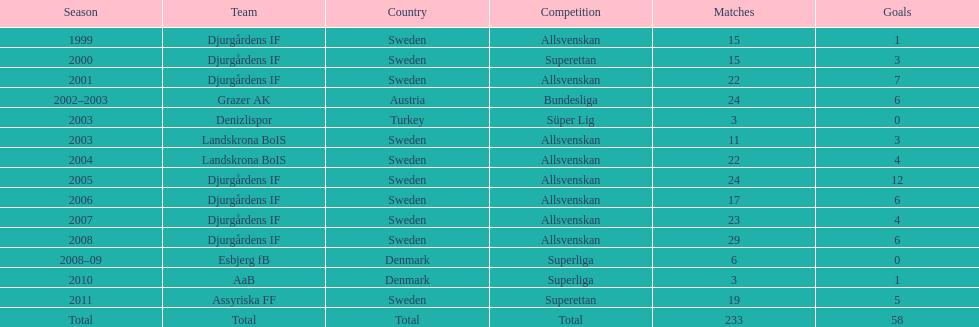Can you parse all the data within this table? {'header': ['Season', 'Team', 'Country', 'Competition', 'Matches', 'Goals'], 'rows': [['1999', 'Djurgårdens IF', 'Sweden', 'Allsvenskan', '15', '1'], ['2000', 'Djurgårdens IF', 'Sweden', 'Superettan', '15', '3'], ['2001', 'Djurgårdens IF', 'Sweden', 'Allsvenskan', '22', '7'], ['2002–2003', 'Grazer AK', 'Austria', 'Bundesliga', '24', '6'], ['2003', 'Denizlispor', 'Turkey', 'Süper Lig', '3', '0'], ['2003', 'Landskrona BoIS', 'Sweden', 'Allsvenskan', '11', '3'], ['2004', 'Landskrona BoIS', 'Sweden', 'Allsvenskan', '22', '4'], ['2005', 'Djurgårdens IF', 'Sweden', 'Allsvenskan', '24', '12'], ['2006', 'Djurgårdens IF', 'Sweden', 'Allsvenskan', '17', '6'], ['2007', 'Djurgårdens IF', 'Sweden', 'Allsvenskan', '23', '4'], ['2008', 'Djurgårdens IF', 'Sweden', 'Allsvenskan', '29', '6'], ['2008–09', 'Esbjerg fB', 'Denmark', 'Superliga', '6', '0'], ['2010', 'AaB', 'Denmark', 'Superliga', '3', '1'], ['2011', 'Assyriska FF', 'Sweden', 'Superettan', '19', '5'], ['Total', 'Total', 'Total', 'Total', '233', '58']]} What was the overall count of matches? 233. 